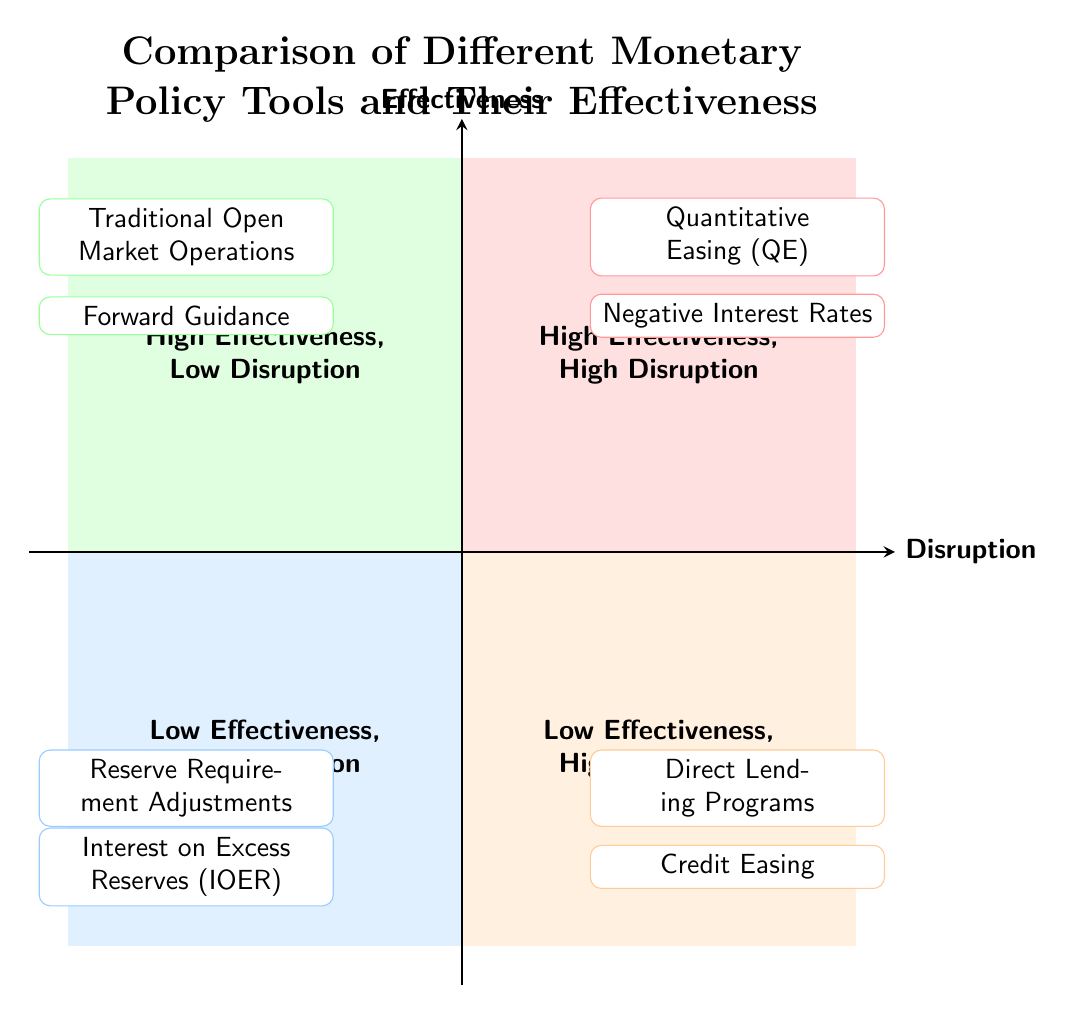What are the two tools located in the "High Effectiveness, High Disruption" quadrant? The tools listed in this quadrant are Quantitative Easing (QE) and Negative Interest Rates. They are positioned in the upper right area of the quadrant chart indicating their effectiveness and disruption level.
Answer: Quantitative Easing (QE), Negative Interest Rates How many tools are listed in the "Low Effectiveness, High Disruption" quadrant? There are two tools listed in this quadrant, which are Direct Lending Programs and Credit Easing. This count is verified by counting the individual entries present in the specified area of the diagram.
Answer: 2 Which monetary policy tool is associated with "Forward Guidance"? Forward Guidance is categorized under the "High Effectiveness, Low Disruption" quadrant. This is determined by identifying the location of Forward Guidance within the framework of the quadrant chart.
Answer: Forward Guidance What distinguishes "Traditional Open Market Operations" from "Negative Interest Rates"? Traditional Open Market Operations is in the "High Effectiveness, Low Disruption" quadrant, while Negative Interest Rates is in the "High Effectiveness, High Disruption" quadrant. The difference is based on their positions in the quadrants regarding their effectiveness and disruption levels.
Answer: Quadrant positions Which quadrant contains tools that have "Low Effectiveness, Low Disruption"? The quadrant that contains tools with "Low Effectiveness, Low Disruption" is located in the lower left section of the diagram. This quadrant includes Reserve Requirement Adjustments and Interest on Excess Reserves (IOER).
Answer: Low Effectiveness, Low Disruption What is the main purpose of "Quantitative Easing"? The main purpose of Quantitative Easing is to purchase long-term securities to increase the money supply and encourage lending and investment. This purpose is provided by the description linked to the tool listed in the quadrant.
Answer: Increase money supply How many quadrants are depicted in the diagram? There are four quadrants depicted in the diagram. This is established by counting the distinct areas formed by the intersections of the axes that categorize the tools based on their effectiveness and disruption.
Answer: 4 What is the significance of placing "Interest on Excess Reserves (IOER)" in the "Low Effectiveness, Low Disruption" quadrant? Placing IOER in this quadrant signifies that while it has a limited impact on overall monetary policy effectiveness, it does not cause significant disruption in the financial system. This categorization reflects its role and the potential consequences of its implementation.
Answer: Limited impact, no disruption 